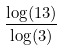<formula> <loc_0><loc_0><loc_500><loc_500>\frac { \log ( 1 3 ) } { \log ( 3 ) }</formula> 